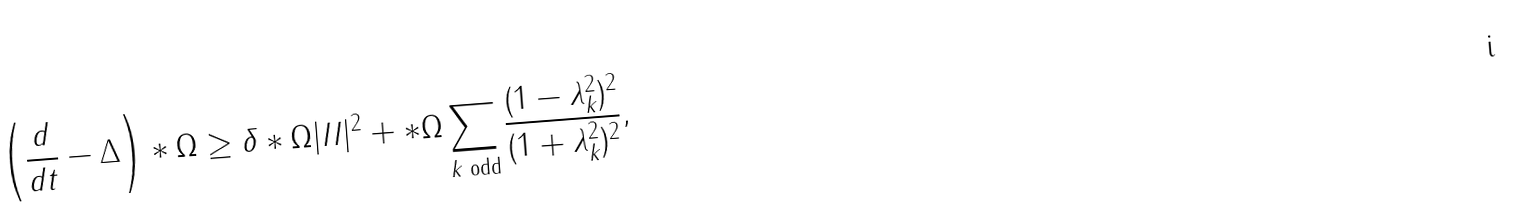Convert formula to latex. <formula><loc_0><loc_0><loc_500><loc_500>\left ( \frac { d } { d t } - \Delta \right ) * \Omega \geq \delta * \Omega | I I | ^ { 2 } + * \Omega \sum _ { k \text { odd} } \frac { ( 1 - \lambda _ { k } ^ { 2 } ) ^ { 2 } } { ( 1 + \lambda _ { k } ^ { 2 } ) ^ { 2 } } ,</formula> 